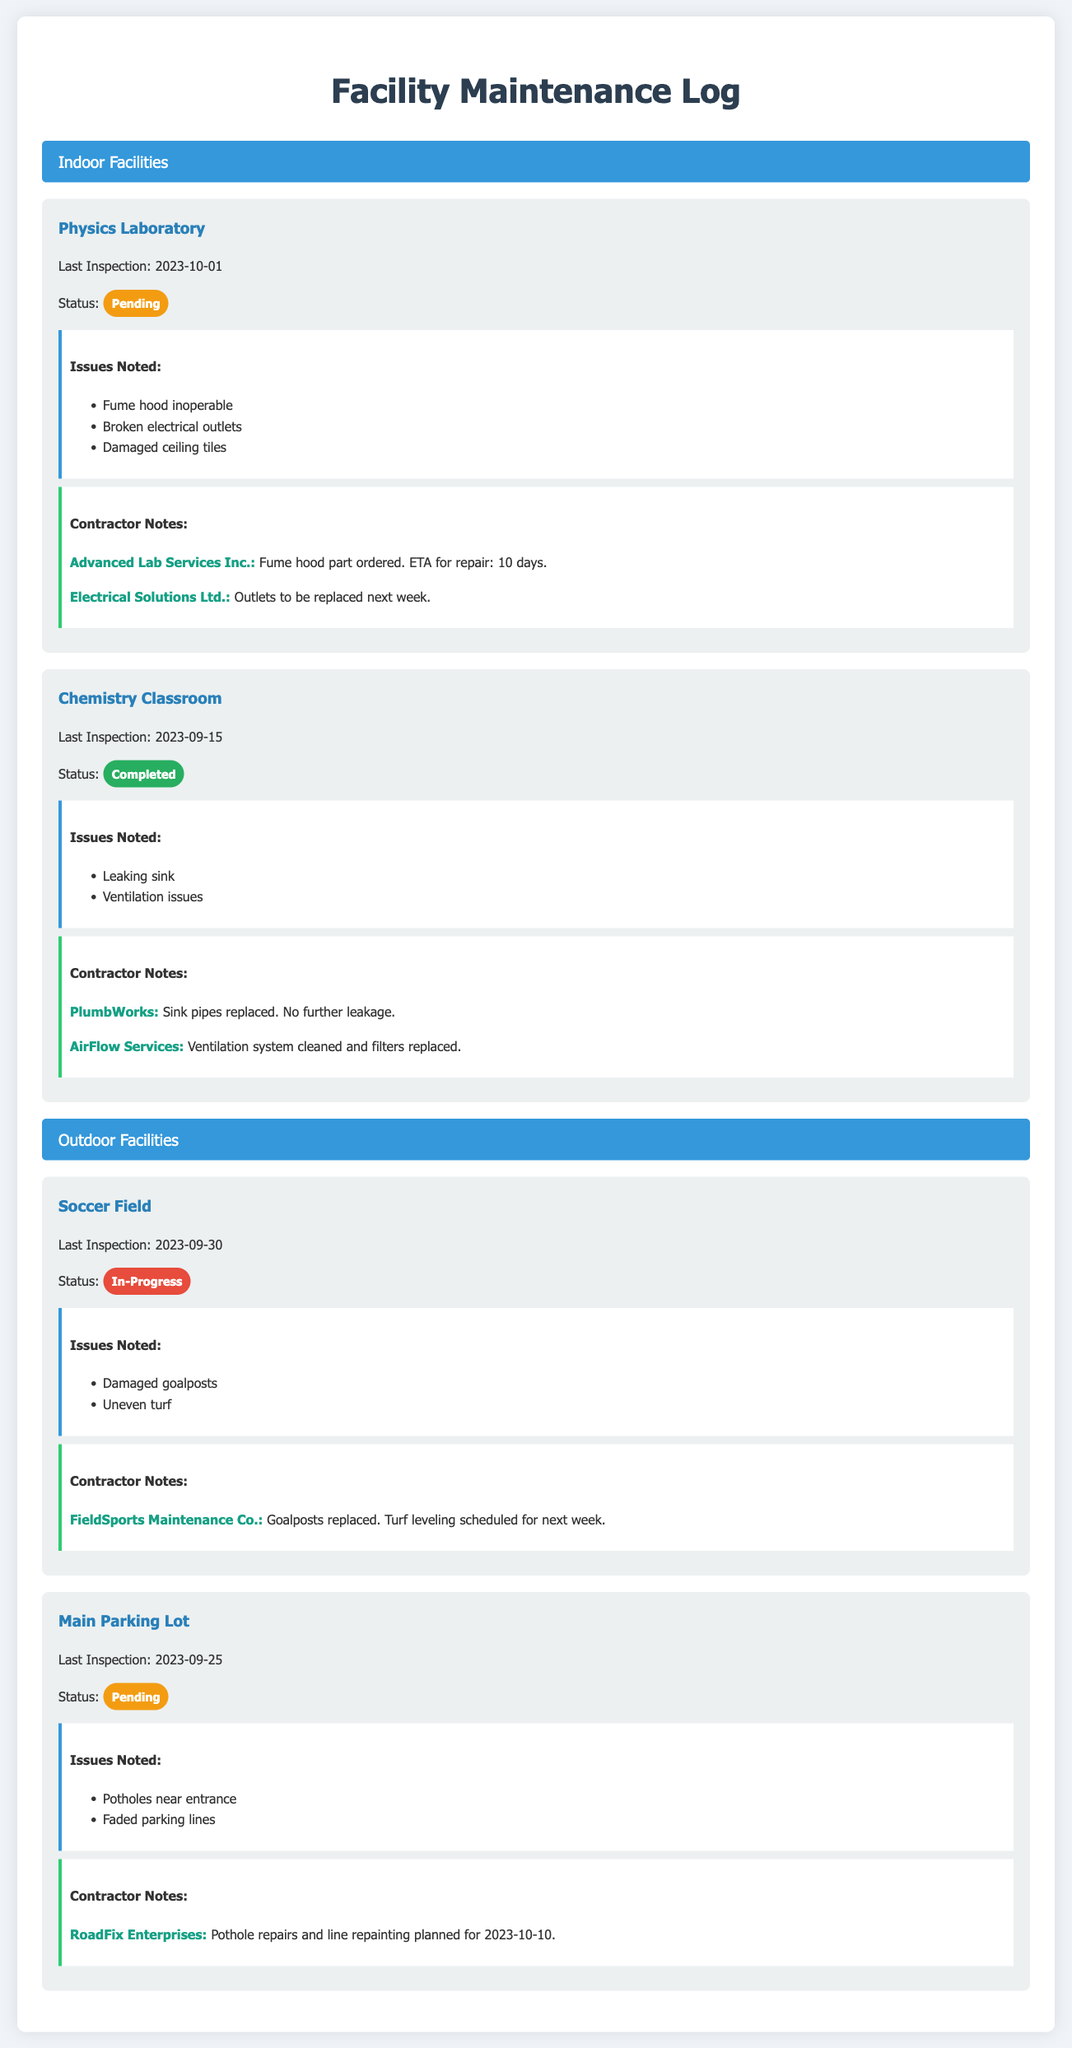What is the status of the Physics Laboratory? The status is explicitly mentioned in the document as "Pending."
Answer: Pending When was the last inspection of the Chemistry Classroom? The date of the last inspection for the Chemistry Classroom is stated as "2023-09-15."
Answer: 2023-09-15 What issue was noted for the Soccer Field? The issues noted for the Soccer Field are listed, including "Damaged goalposts."
Answer: Damaged goalposts Who is responsible for the repairs of the Main Parking Lot? The contractor responsible for the Main Parking Lot is specified as "RoadFix Enterprises."
Answer: RoadFix Enterprises What is the ETA for the fume hood repair in the Physics Laboratory? The ETA for the fume hood repair is mentioned as "10 days."
Answer: 10 days Which facility has completed its status? The completed status facility is identified in the document as the "Chemistry Classroom."
Answer: Chemistry Classroom What issues were noted during the inspection of the Physics Laboratory? The document lists several items under "Issues Noted," such as "Fume hood inoperable."
Answer: Fume hood inoperable What service is scheduled for next week in the Soccer Field? The document states that "Turf leveling" is scheduled for next week.
Answer: Turf leveling Who replaced the sink pipes in the Chemistry Classroom? The contractor that replaced the sink pipes is named "PlumbWorks."
Answer: PlumbWorks 